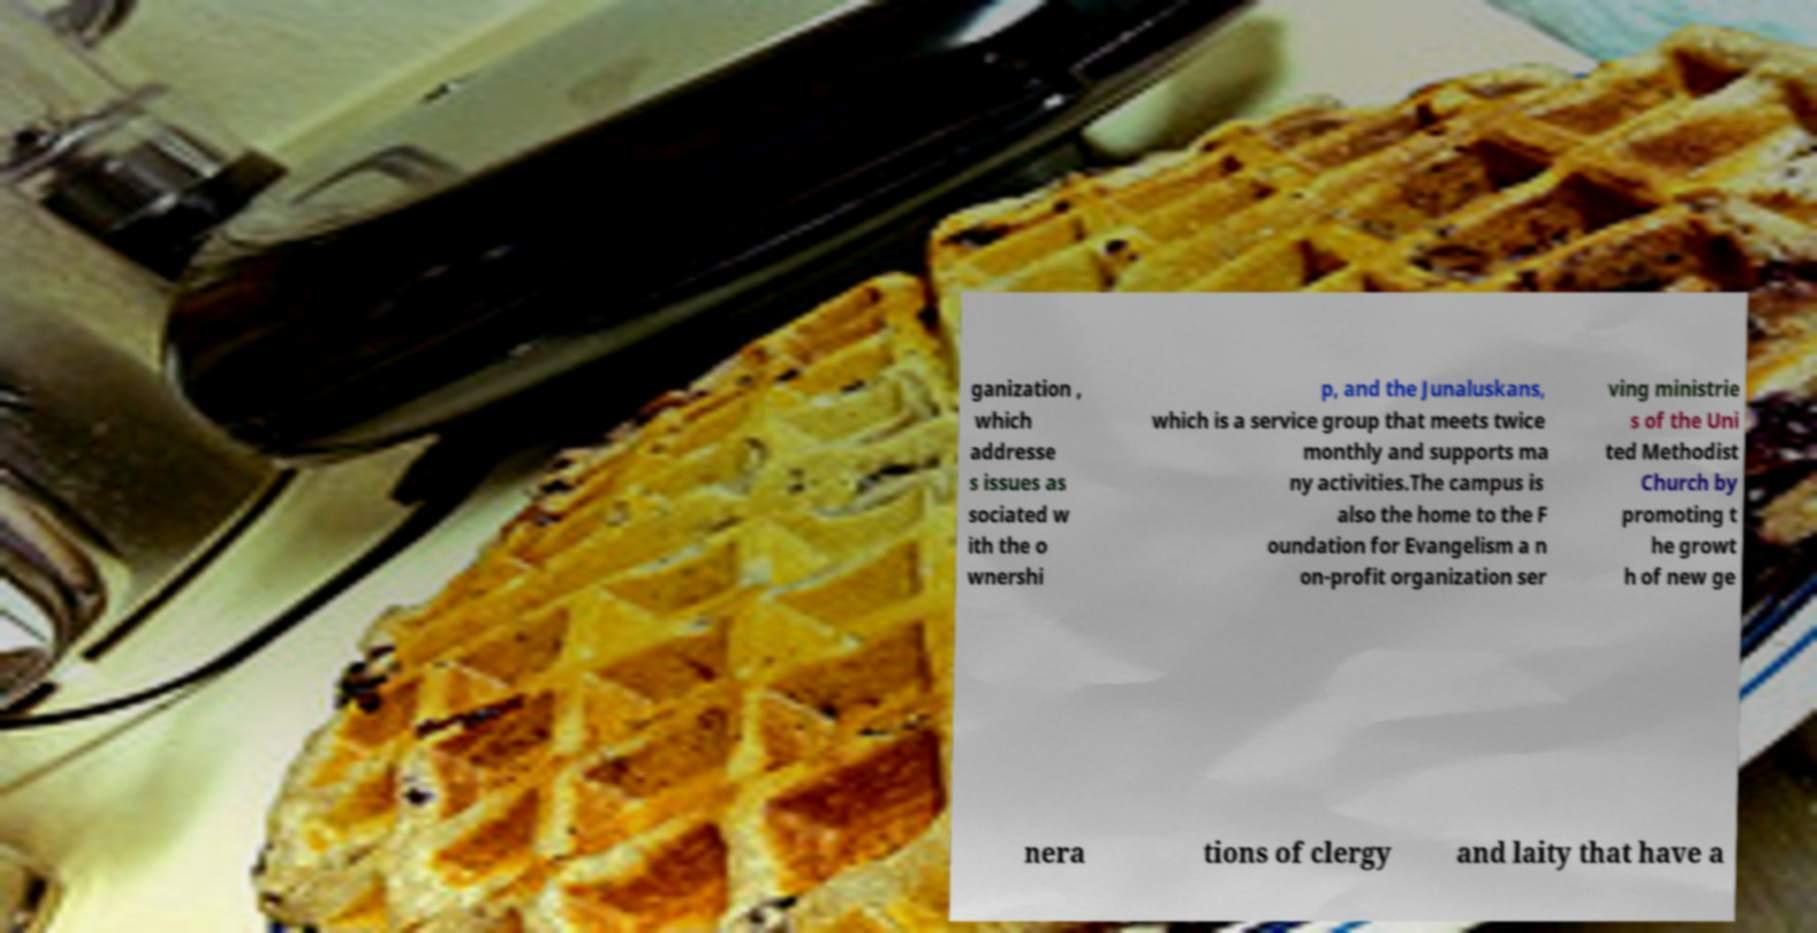Please identify and transcribe the text found in this image. ganization , which addresse s issues as sociated w ith the o wnershi p, and the Junaluskans, which is a service group that meets twice monthly and supports ma ny activities.The campus is also the home to the F oundation for Evangelism a n on-profit organization ser ving ministrie s of the Uni ted Methodist Church by promoting t he growt h of new ge nera tions of clergy and laity that have a 